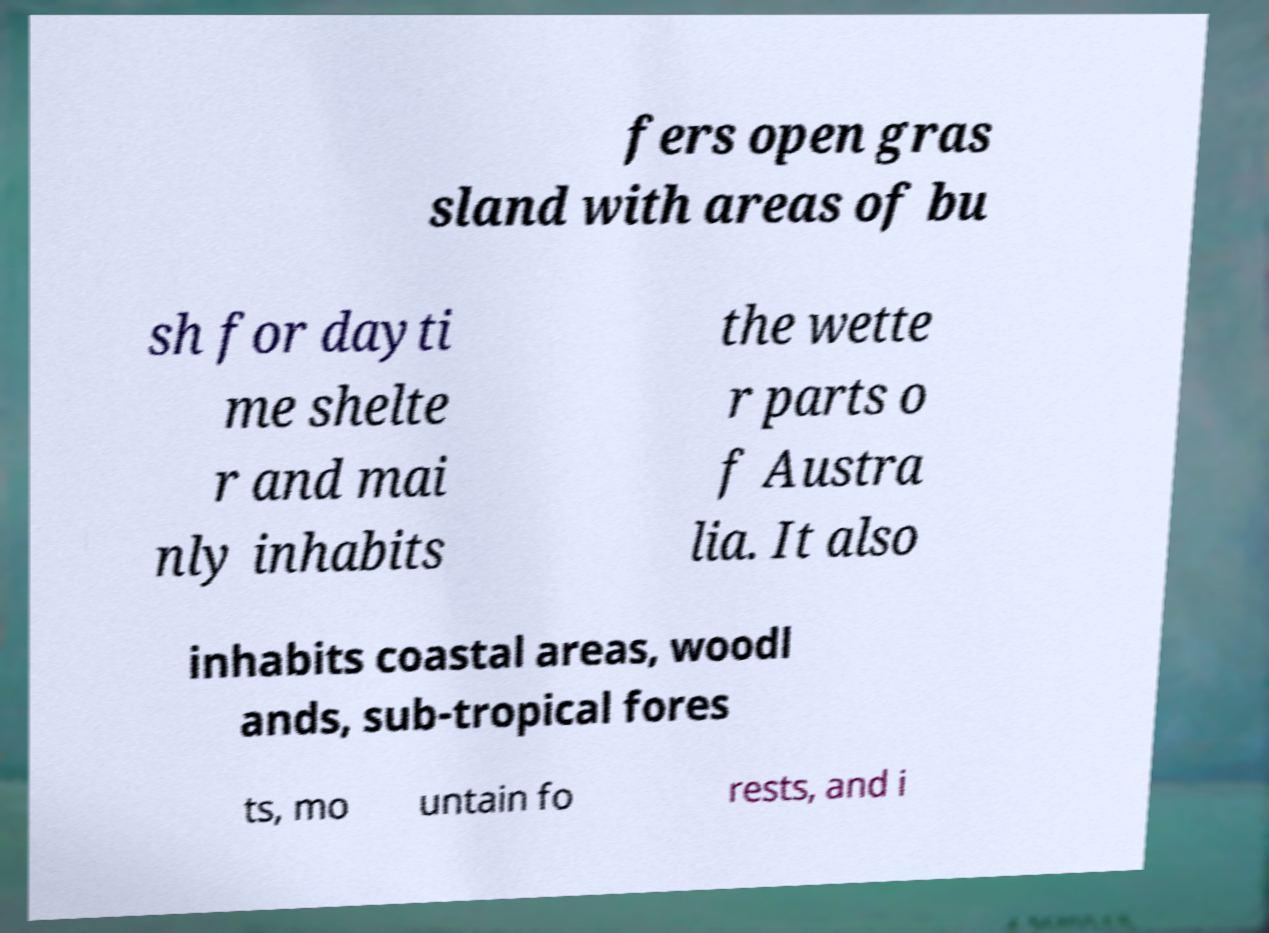There's text embedded in this image that I need extracted. Can you transcribe it verbatim? fers open gras sland with areas of bu sh for dayti me shelte r and mai nly inhabits the wette r parts o f Austra lia. It also inhabits coastal areas, woodl ands, sub-tropical fores ts, mo untain fo rests, and i 